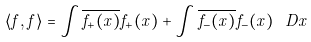<formula> <loc_0><loc_0><loc_500><loc_500>\langle f , f \rangle = \int \overline { f _ { + } ( x ) } f _ { + } ( x ) + \int \overline { f _ { - } ( x ) } f _ { - } ( x ) \ D x</formula> 